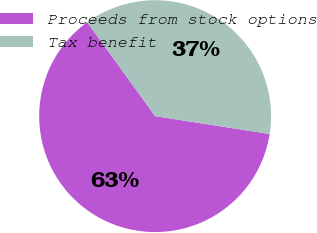Convert chart. <chart><loc_0><loc_0><loc_500><loc_500><pie_chart><fcel>Proceeds from stock options<fcel>Tax benefit<nl><fcel>62.58%<fcel>37.42%<nl></chart> 